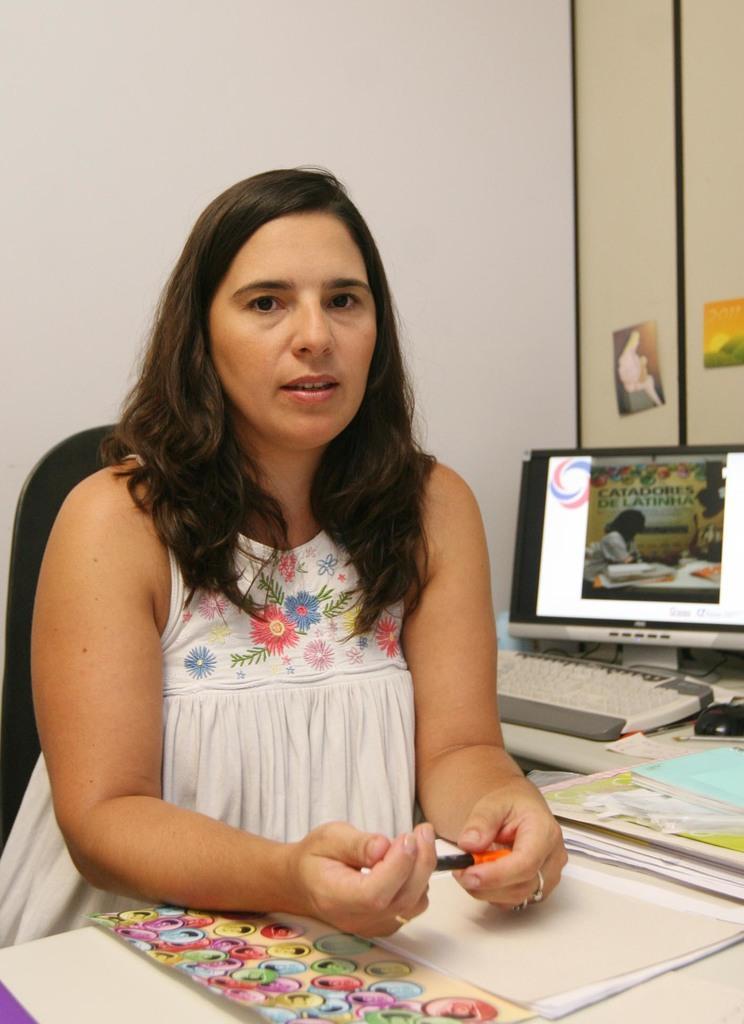Describe this image in one or two sentences. In this image we can see a woman is sitting on a black chair and wearing white color top. In front of her papers are there on the table, left of her computer is present. The walls of the room is in white color. 